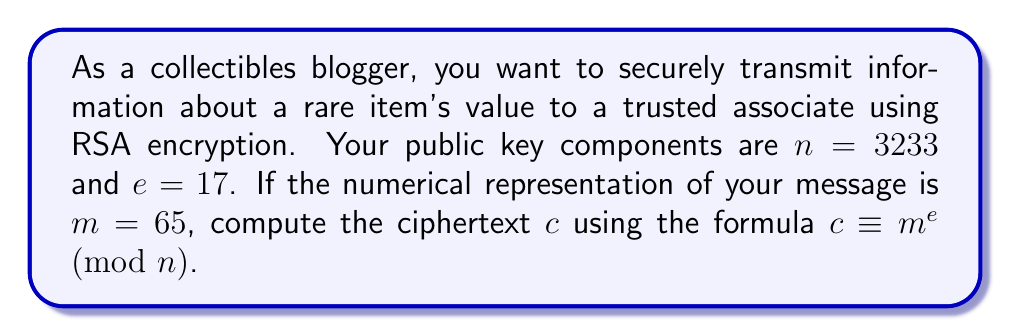Teach me how to tackle this problem. To compute the modular exponentiation for RSA encryption, we need to calculate $c \equiv m^e \pmod{n}$. Let's break this down step-by-step:

1) We have:
   $m = 65$
   $e = 17$
   $n = 3233$

2) We need to calculate $65^{17} \pmod{3233}$

3) Direct computation of $65^{17}$ would result in a very large number. Instead, we can use the square-and-multiply algorithm:

   $65^1 \equiv 65 \pmod{3233}$
   $65^2 \equiv 65^1 \cdot 65^1 \equiv 4225 \equiv 992 \pmod{3233}$
   $65^4 \equiv 992^2 \equiv 984064 \equiv 2893 \pmod{3233}$
   $65^8 \equiv 2893^2 \equiv 8369449 \equiv 2260 \pmod{3233}$
   $65^{16} \equiv 2260^2 \equiv 5107600 \equiv 2098 \pmod{3233}$

4) Now, $17 = 16 + 1$, so:
   $65^{17} \equiv 65^{16} \cdot 65^1 \pmod{3233}$
   $\equiv 2098 \cdot 65 \pmod{3233}$
   $\equiv 136370 \pmod{3233}$
   $\equiv 2790 \pmod{3233}$

Therefore, the ciphertext $c$ is 2790.
Answer: $c = 2790$ 